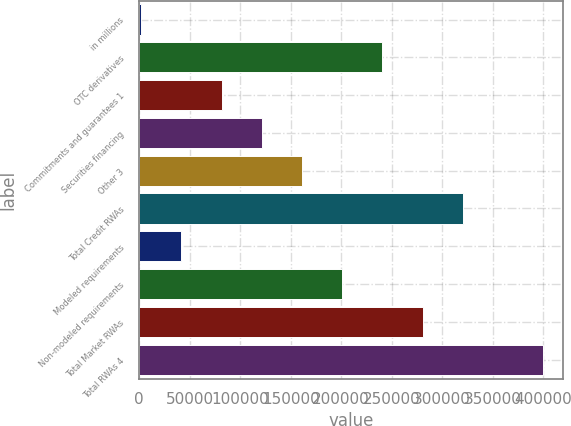Convert chart to OTSL. <chart><loc_0><loc_0><loc_500><loc_500><bar_chart><fcel>in millions<fcel>OTC derivatives<fcel>Commitments and guarantees 1<fcel>Securities financing<fcel>Other 3<fcel>Total Credit RWAs<fcel>Modeled requirements<fcel>Non-modeled requirements<fcel>Total Market RWAs<fcel>Total RWAs 4<nl><fcel>2012<fcel>240762<fcel>81595.2<fcel>121387<fcel>161178<fcel>320345<fcel>41803.6<fcel>200970<fcel>280553<fcel>399928<nl></chart> 